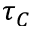Convert formula to latex. <formula><loc_0><loc_0><loc_500><loc_500>\tau _ { C }</formula> 